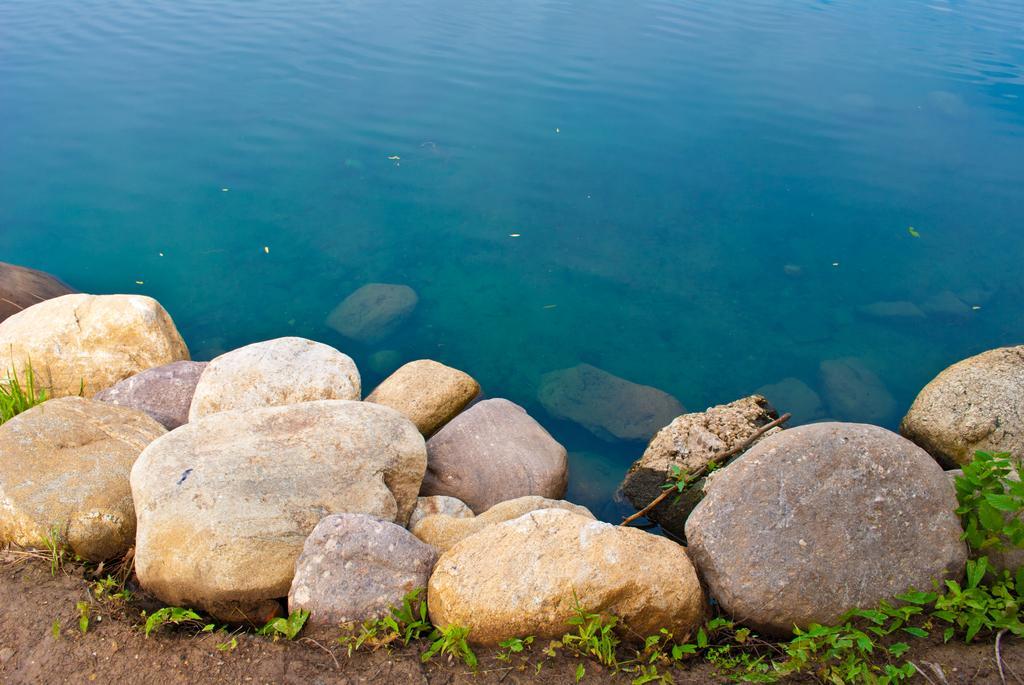Describe this image in one or two sentences. In the background of the image we can see the water. At the bottom of the image we can see the rocks, plants and ground. 